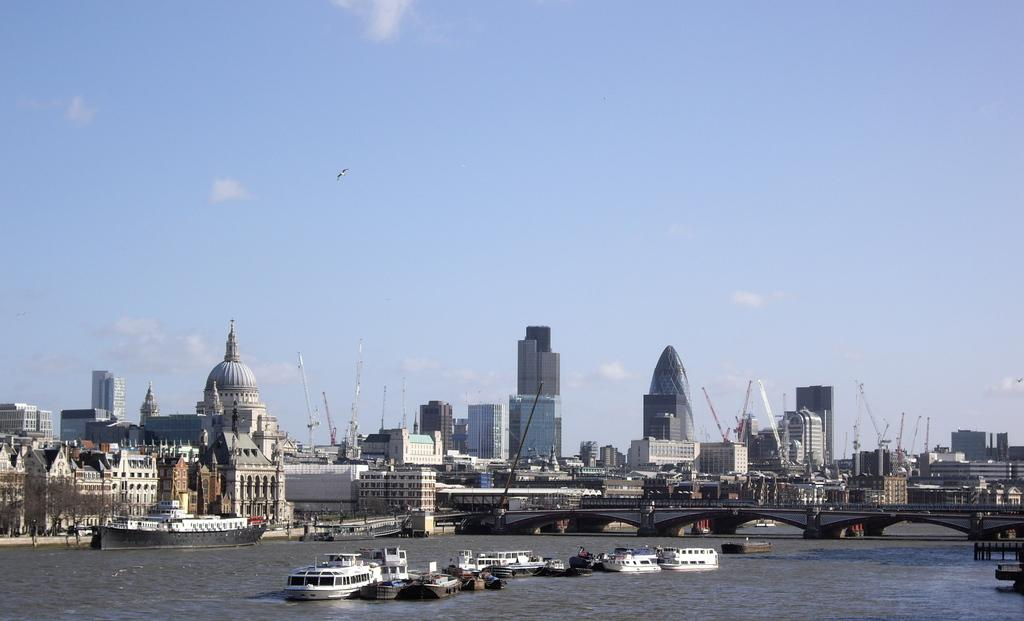What can be seen in the background of the image? In the background of the image, there is a sky with clouds, skyscrapers, and other buildings. What type of structure is present in the image? There is a bridge in the image. What body of water is visible in the image? There is water in the image, and boats and a ship are present on it. What are the poles in the image used for? The purpose of the poles in the image is not specified, but they could be used for various purposes such as signage or lighting. What type of vegetation is on the left side of the image? There are trees on the left side of the image. What type of canvas is used to create the texture of the sky in the image? The image is a photograph, not a painting, so there is no canvas or texture applied to the sky. 